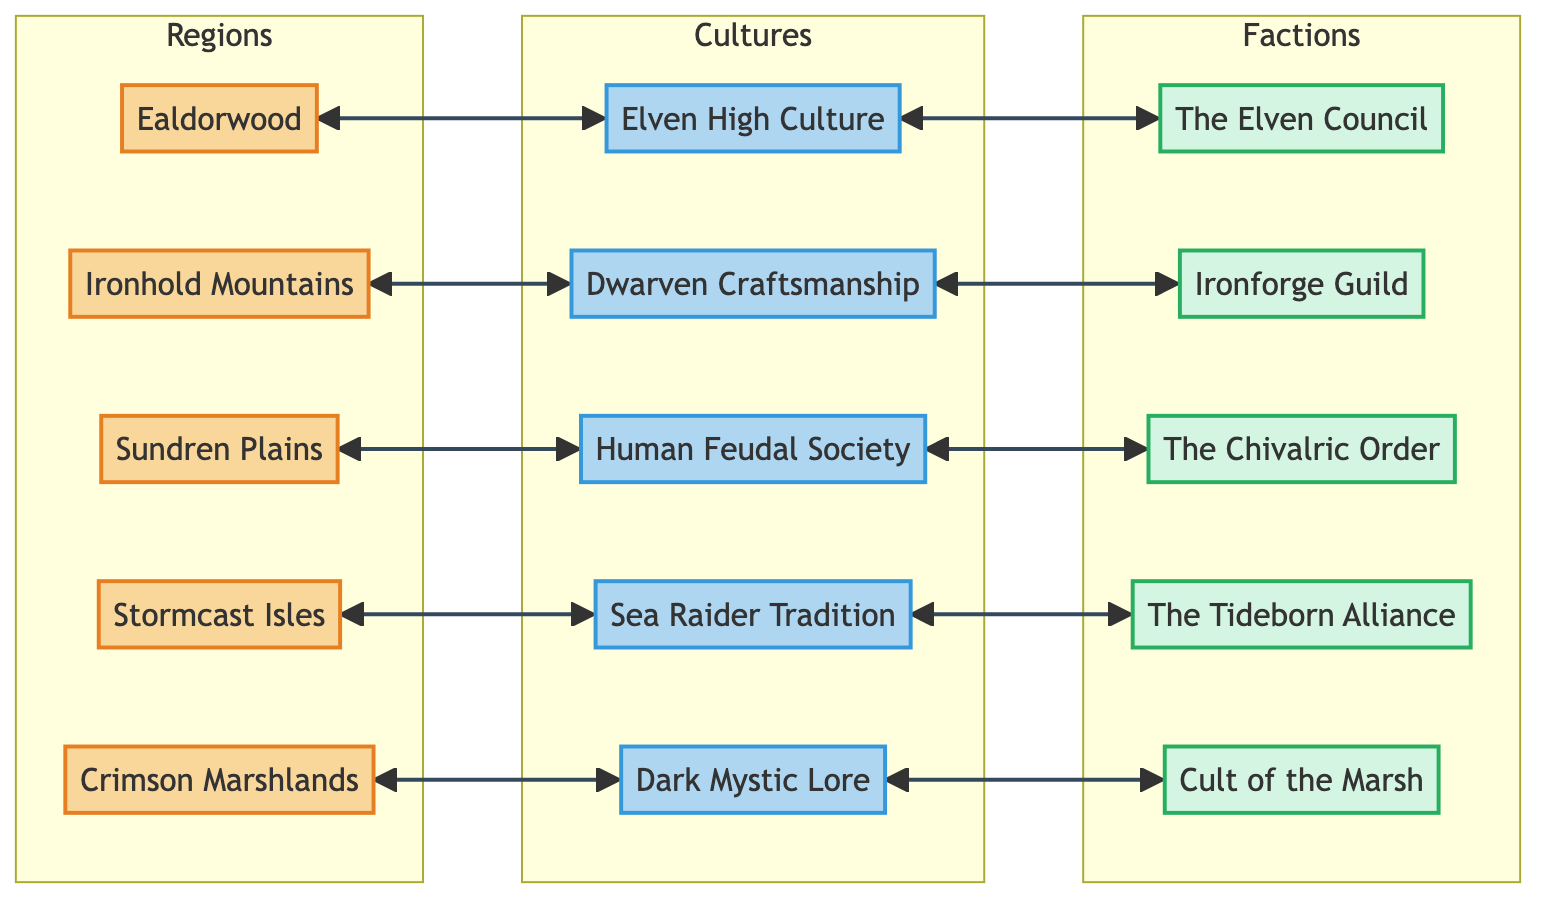What is the total number of regions depicted in the diagram? The diagram has five nodes labeled as regions: Ealdorwood, Ironhold Mountains, Sundren Plains, Stormcast Isles, and Crimson Marshlands, which counts to a total of five distinct regions.
Answer: 5 Which culture is associated with the Ealdorwood region? The Ealdorwood region has a link to the Elven High Culture, demonstrating that this culture thrives in that area.
Answer: Elven High Culture What is the relationship between the Dwarven Craftsmanship culture and the Ironforge Guild faction? The Dwarven Craftsmanship culture connects to the Ironforge Guild faction through a bi-directional link, indicating that they share a close relationship within the context of the Ironhold Mountains.
Answer: They are connected How many factions are there in total in the diagram? The diagram lists five factions: The Elven Council, Ironforge Guild, The Chivalric Order, The Tideborn Alliance, and Cult of the Marsh, totaling five factions present in the framework.
Answer: 5 Which faction is linked to the Dark Mystic Lore culture? The Dark Mystic Lore culture has a connection to the Cult of the Marsh faction, revealing their interaction within the Crimson Marshlands.
Answer: Cult of the Marsh Where do the Sea Raider Tradition and The Tideborn Alliance intersect? Both nodes have a direct link, indicating that the Sea Raider Tradition culture leads into the Tideborn Alliance faction, showing their relationship centered around the Stormcast Isles.
Answer: They intersect Identify the region connected to the Chivalric Order faction. The Chivalric Order faction is linked to the Sundren Plains region, indicating that this knightly faction operates within that area.
Answer: Sundren Plains Which culture practices dark magic? The Dark Mystic Lore culture is indicated as practicing dark magic, tying it closely to its associated region, the Crimson Marshlands.
Answer: Dark Mystic Lore What is the main theme of the Elven Council faction? The Elven Council is primarily a governing body that makes decisions for the Ealdorwood region and its inhabitants, focusing on elven governance.
Answer: Governance 